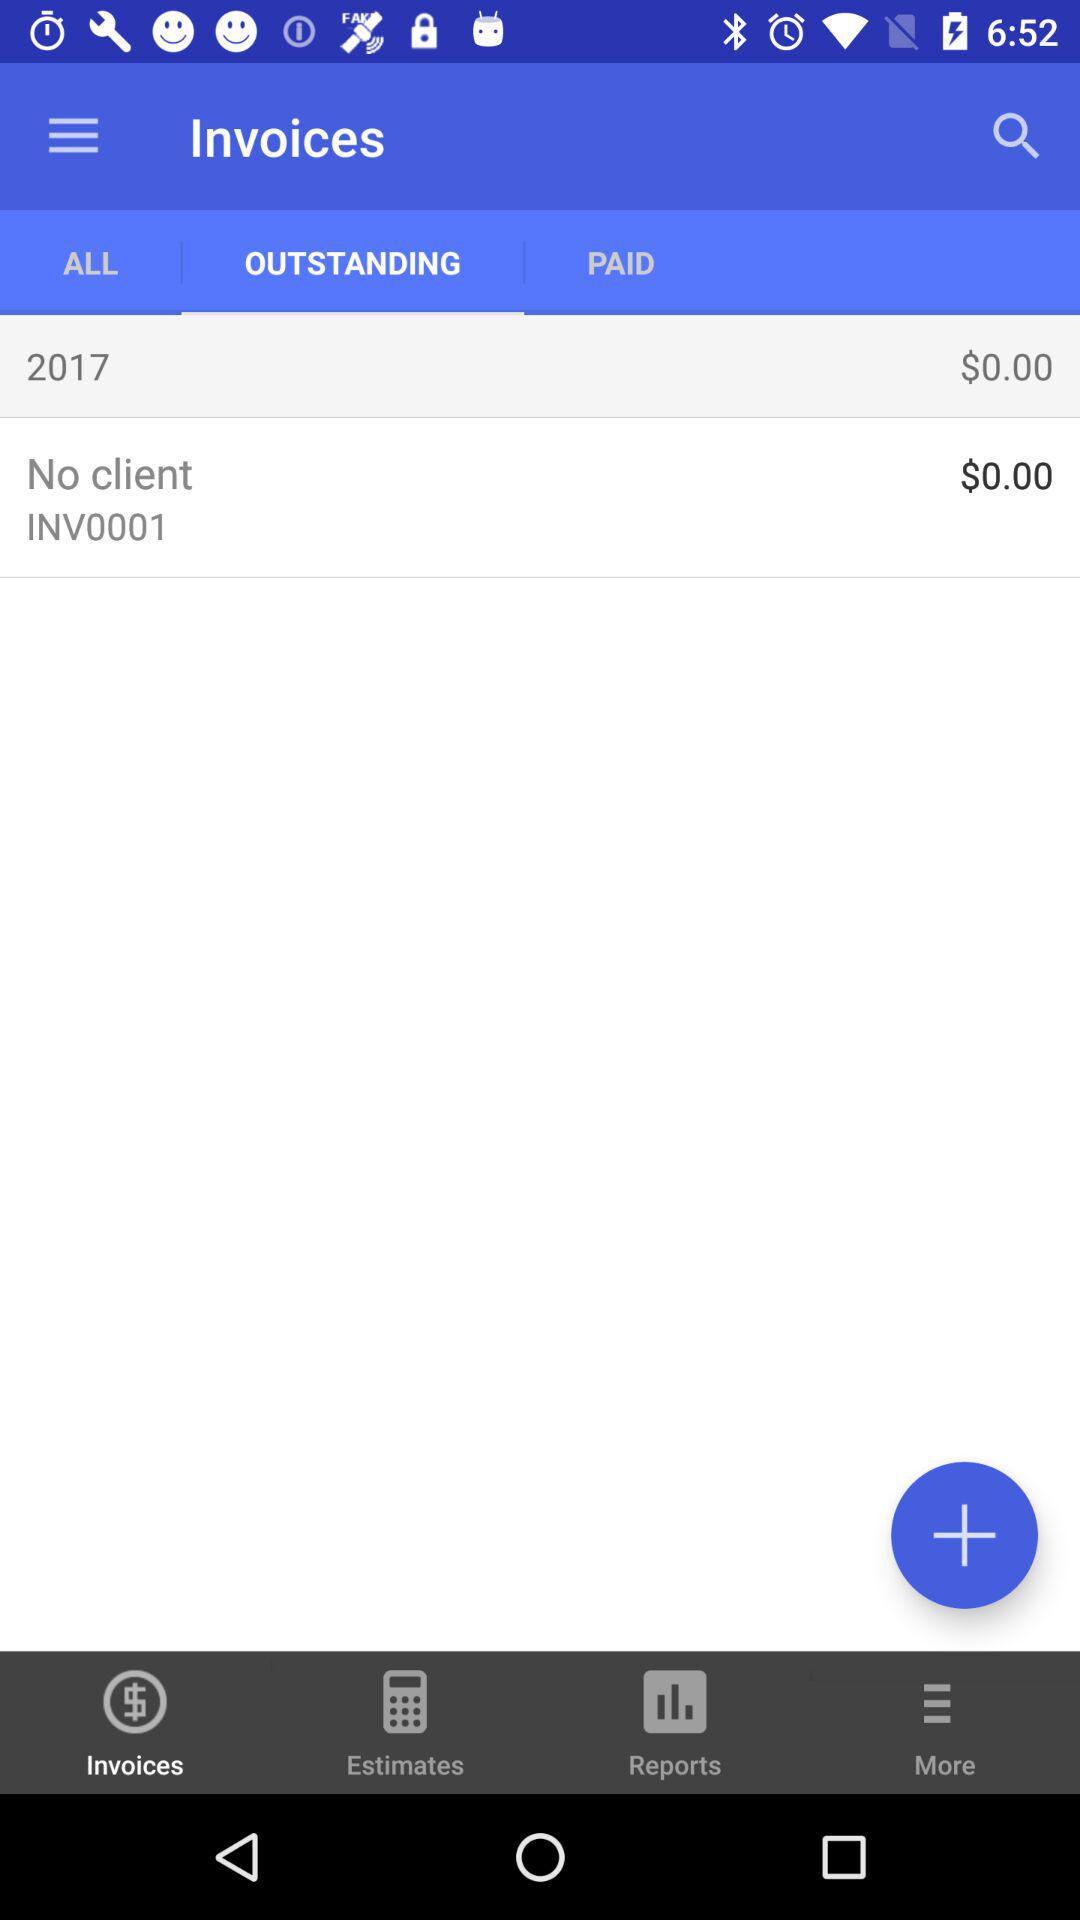Which option is selected in "Invoices"? The selected option is "OUTSTANDING". 